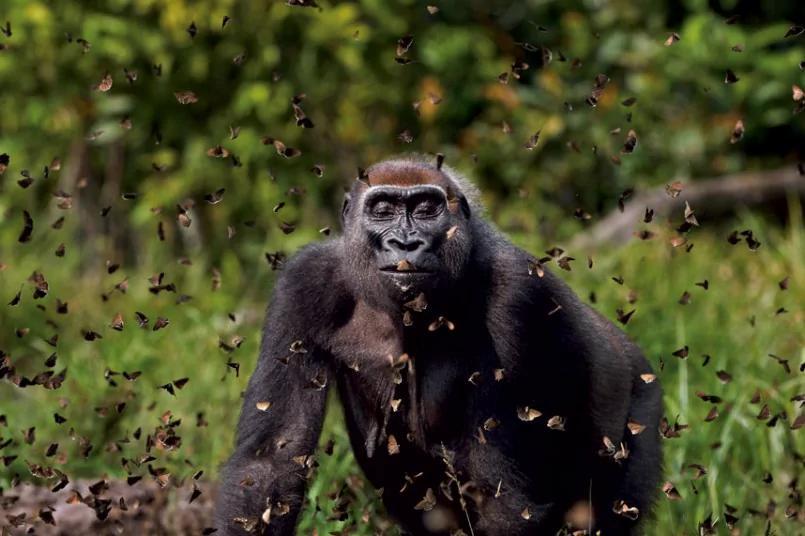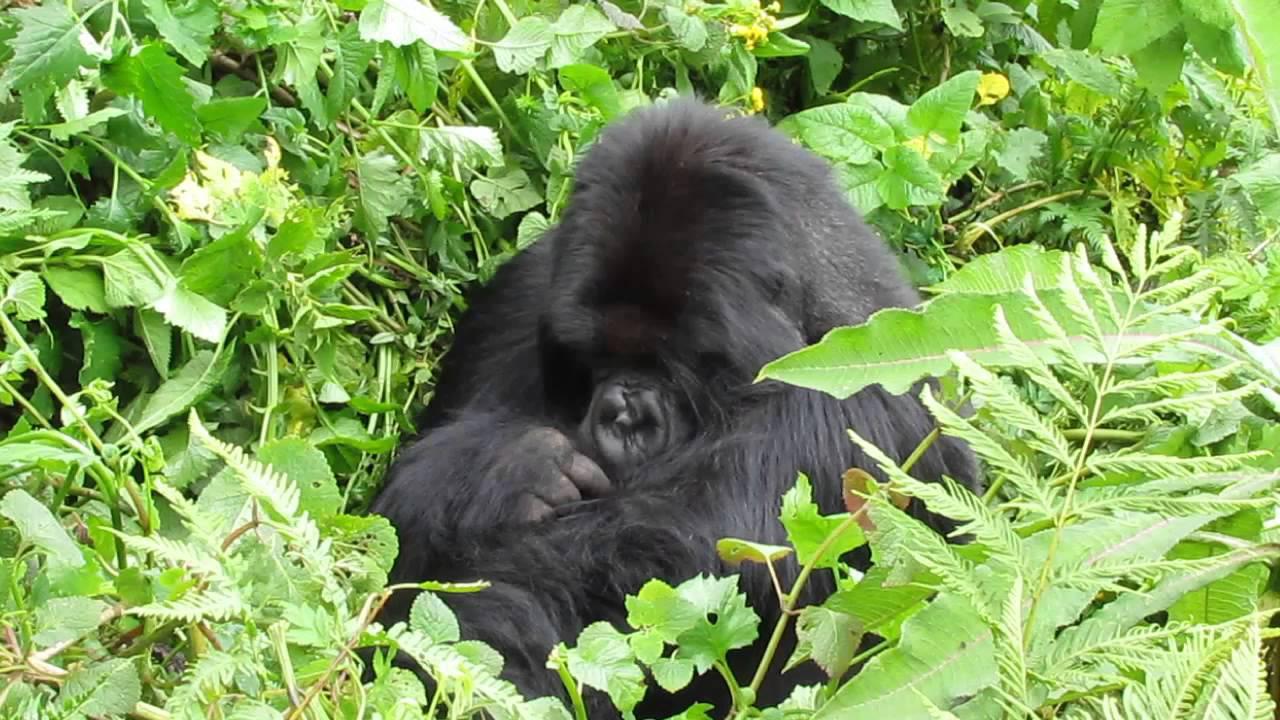The first image is the image on the left, the second image is the image on the right. Examine the images to the left and right. Is the description "One primate is carrying a younger primate." accurate? Answer yes or no. No. The first image is the image on the left, the second image is the image on the right. Evaluate the accuracy of this statement regarding the images: "One image shows just one gorilla, a male on all fours with its body turned leftward, and the other image contains two apes, one a tiny baby.". Is it true? Answer yes or no. No. 